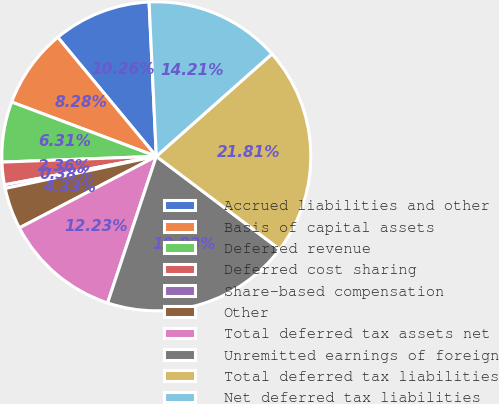<chart> <loc_0><loc_0><loc_500><loc_500><pie_chart><fcel>Accrued liabilities and other<fcel>Basis of capital assets<fcel>Deferred revenue<fcel>Deferred cost sharing<fcel>Share-based compensation<fcel>Other<fcel>Total deferred tax assets net<fcel>Unremitted earnings of foreign<fcel>Total deferred tax liabilities<fcel>Net deferred tax liabilities<nl><fcel>10.26%<fcel>8.28%<fcel>6.31%<fcel>2.36%<fcel>0.38%<fcel>4.33%<fcel>12.23%<fcel>19.83%<fcel>21.81%<fcel>14.21%<nl></chart> 